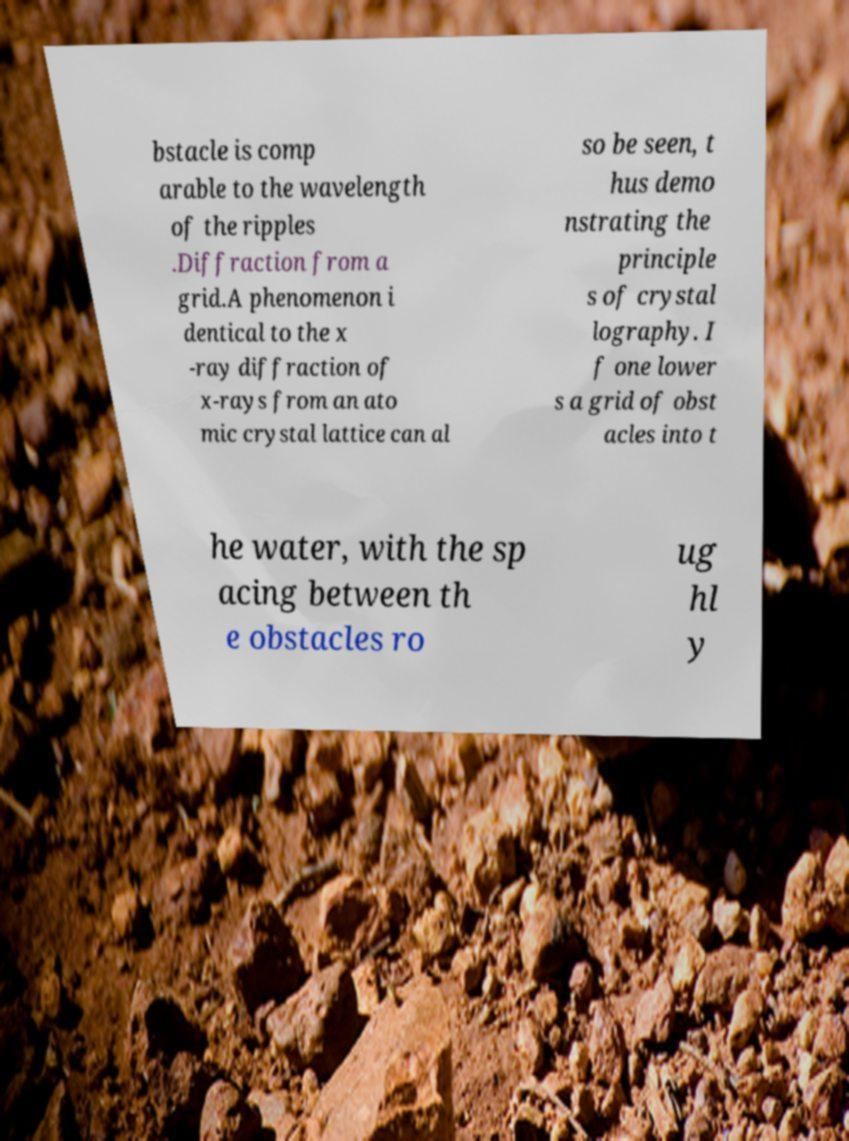I need the written content from this picture converted into text. Can you do that? bstacle is comp arable to the wavelength of the ripples .Diffraction from a grid.A phenomenon i dentical to the x -ray diffraction of x-rays from an ato mic crystal lattice can al so be seen, t hus demo nstrating the principle s of crystal lography. I f one lower s a grid of obst acles into t he water, with the sp acing between th e obstacles ro ug hl y 